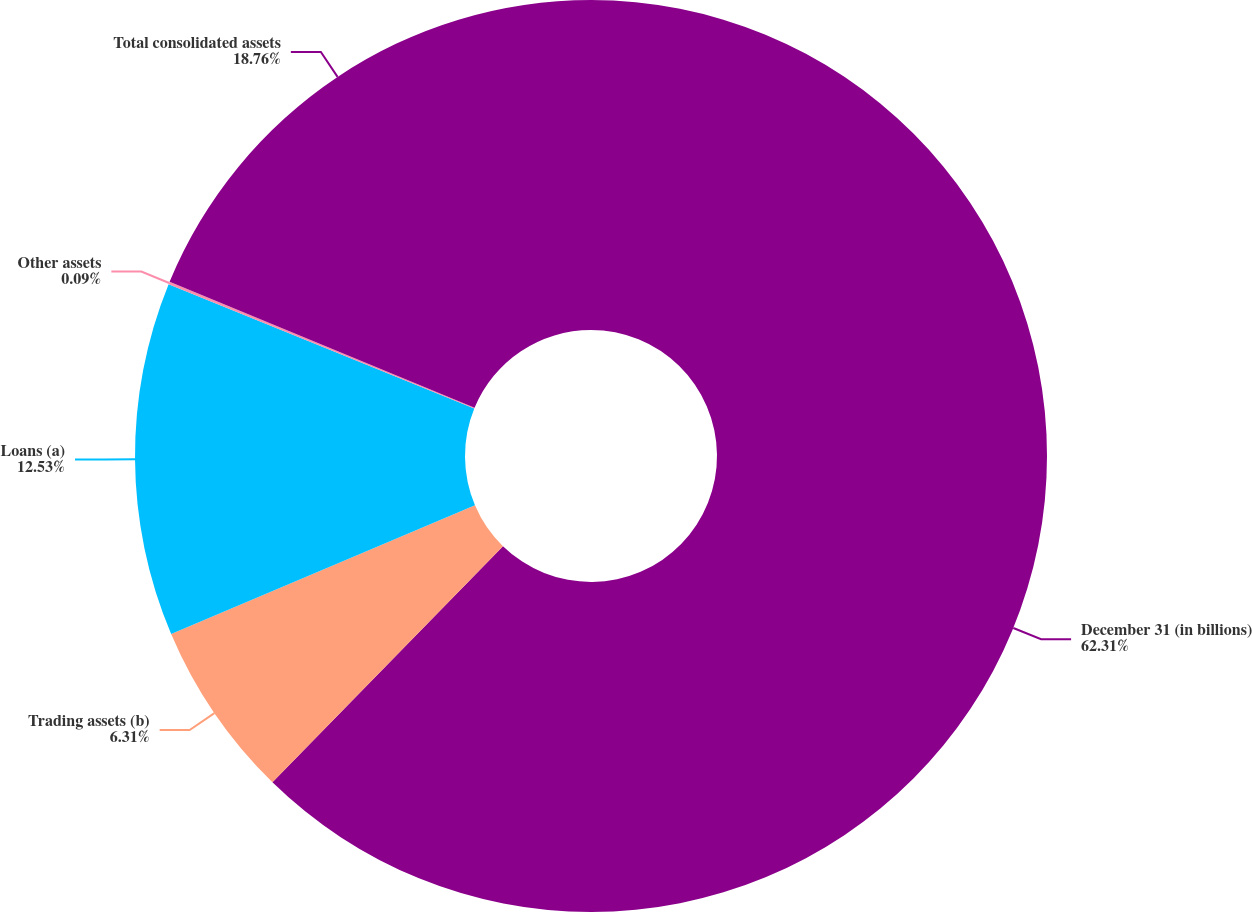Convert chart to OTSL. <chart><loc_0><loc_0><loc_500><loc_500><pie_chart><fcel>December 31 (in billions)<fcel>Trading assets (b)<fcel>Loans (a)<fcel>Other assets<fcel>Total consolidated assets<nl><fcel>62.31%<fcel>6.31%<fcel>12.53%<fcel>0.09%<fcel>18.76%<nl></chart> 